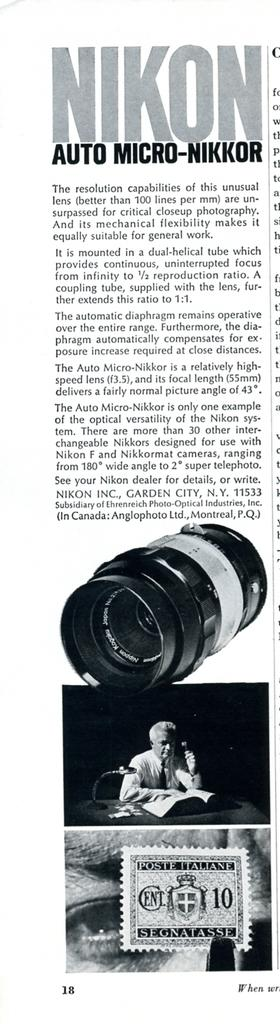What type of images are present in the picture? There are photos of people in the image. Are there any other items or objects visible in the image? Yes, there are other objects in the image. Can you describe the color scheme of the photos? The photos are black and white in color. Is there any text or writing present in the image? Yes, there is writing on the image. How does the honey contribute to the fear in the image? There is no honey or fear present in the image; it only contains photos of people, other objects, and writing. 